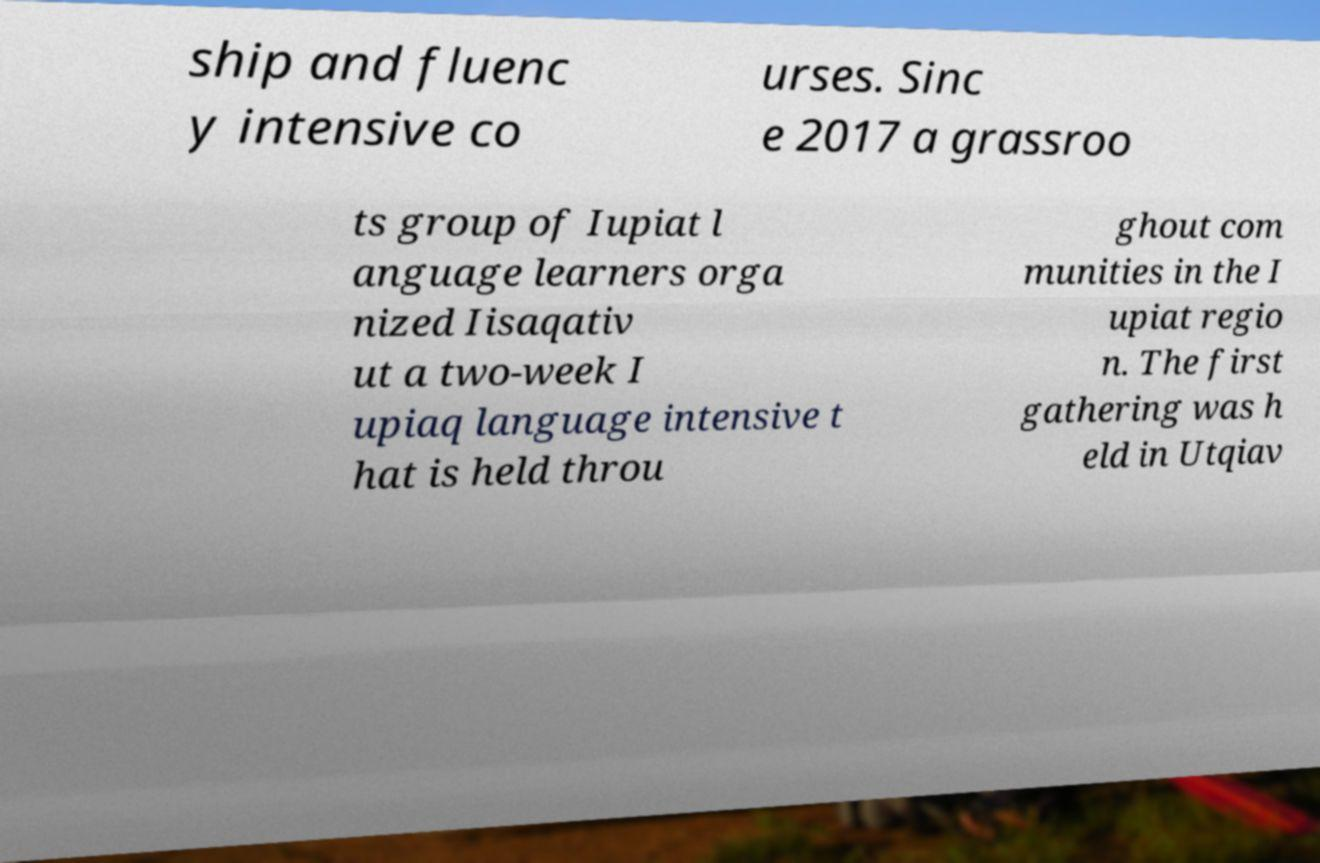For documentation purposes, I need the text within this image transcribed. Could you provide that? ship and fluenc y intensive co urses. Sinc e 2017 a grassroo ts group of Iupiat l anguage learners orga nized Iisaqativ ut a two-week I upiaq language intensive t hat is held throu ghout com munities in the I upiat regio n. The first gathering was h eld in Utqiav 